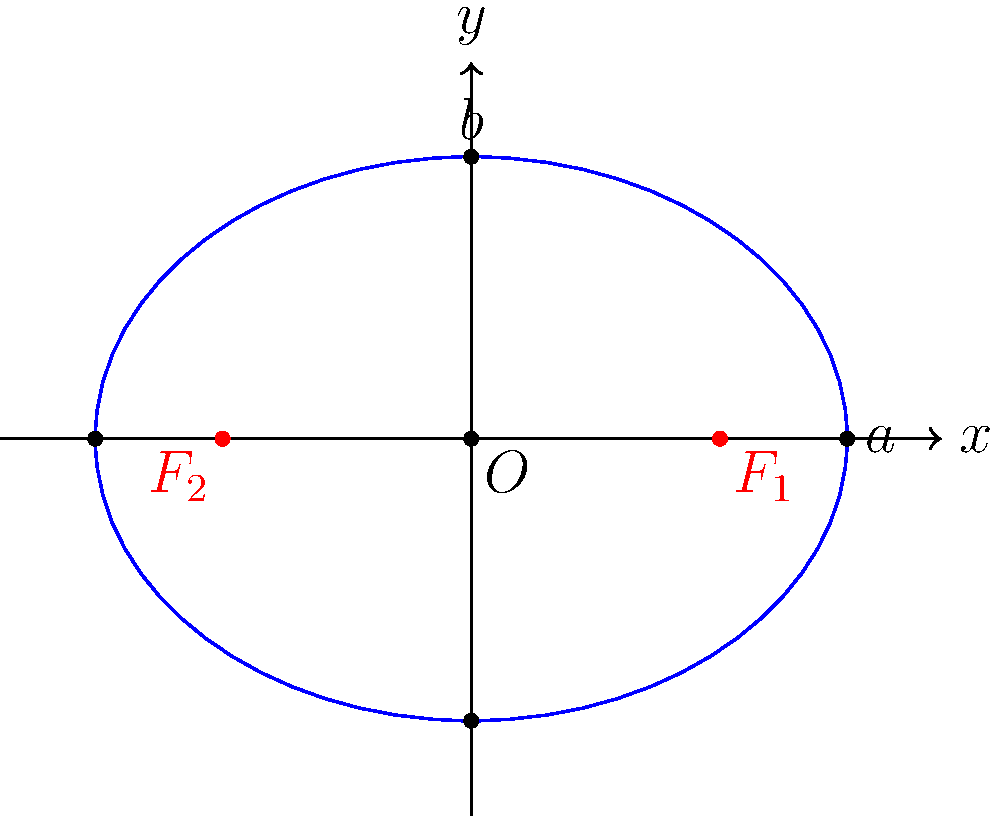In a model of law enforcement agency expansion across a state, an elliptical region is used to represent the area of influence. The foci of the ellipse represent two major city centers, and the ellipse equation is given by $\frac{x^2}{16} + \frac{y^2}{9} = 1$. What is the distance between the two city centers (foci)? To find the distance between the foci, we need to follow these steps:

1) The general equation of an ellipse is $\frac{x^2}{a^2} + \frac{y^2}{b^2} = 1$, where $a$ is the length of the semi-major axis and $b$ is the length of the semi-minor axis.

2) From our given equation $\frac{x^2}{16} + \frac{y^2}{9} = 1$, we can deduce:
   $a^2 = 16$, so $a = 4$
   $b^2 = 9$, so $b = 3$

3) In an ellipse, the distance from the center to a focus is given by $c$, where $c^2 = a^2 - b^2$

4) Calculating $c$:
   $c^2 = a^2 - b^2 = 4^2 - 3^2 = 16 - 9 = 7$
   $c = \sqrt{7}$

5) The distance between the foci is $2c$, so the final answer is $2\sqrt{7}$.

This model shows how the influence of law enforcement agencies might spread from two major city centers, with the elliptical shape representing the combined area of influence.
Answer: $2\sqrt{7}$ 